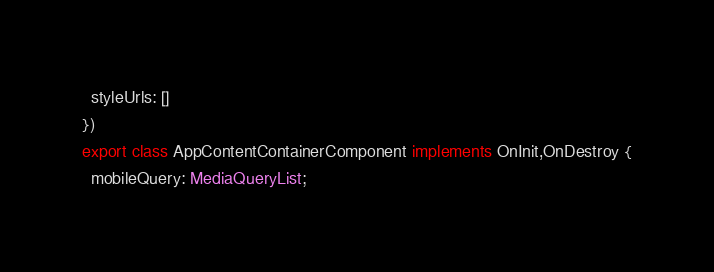Convert code to text. <code><loc_0><loc_0><loc_500><loc_500><_TypeScript_>  styleUrls: []
})
export class AppContentContainerComponent implements OnInit,OnDestroy {
  mobileQuery: MediaQueryList;
</code> 